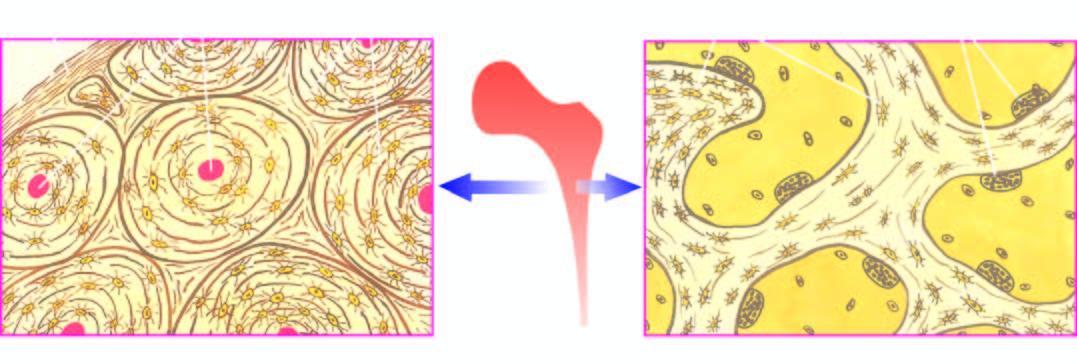what shows trabeculae with osteoclastic activity at the margins?
Answer the question using a single word or phrase. Trabecular bone forming the marrow space 